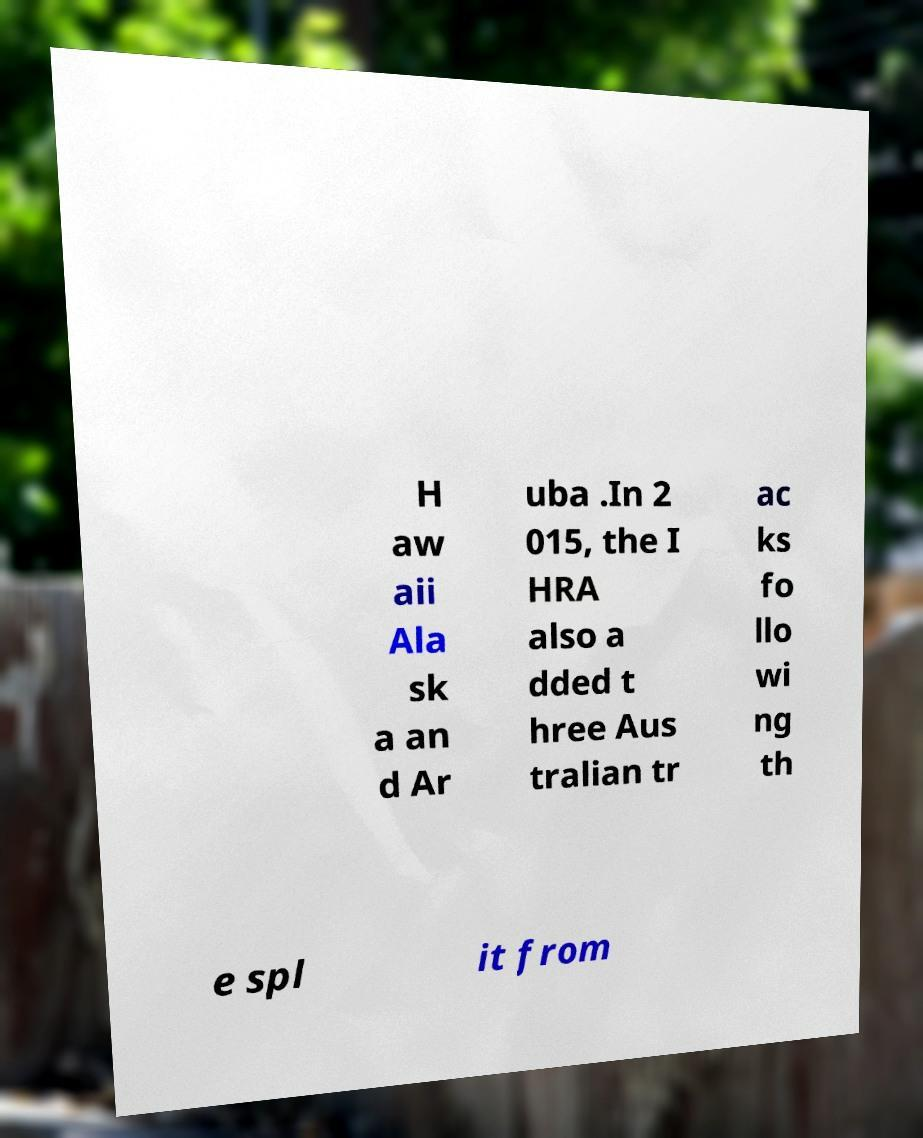Can you read and provide the text displayed in the image?This photo seems to have some interesting text. Can you extract and type it out for me? H aw aii Ala sk a an d Ar uba .In 2 015, the I HRA also a dded t hree Aus tralian tr ac ks fo llo wi ng th e spl it from 